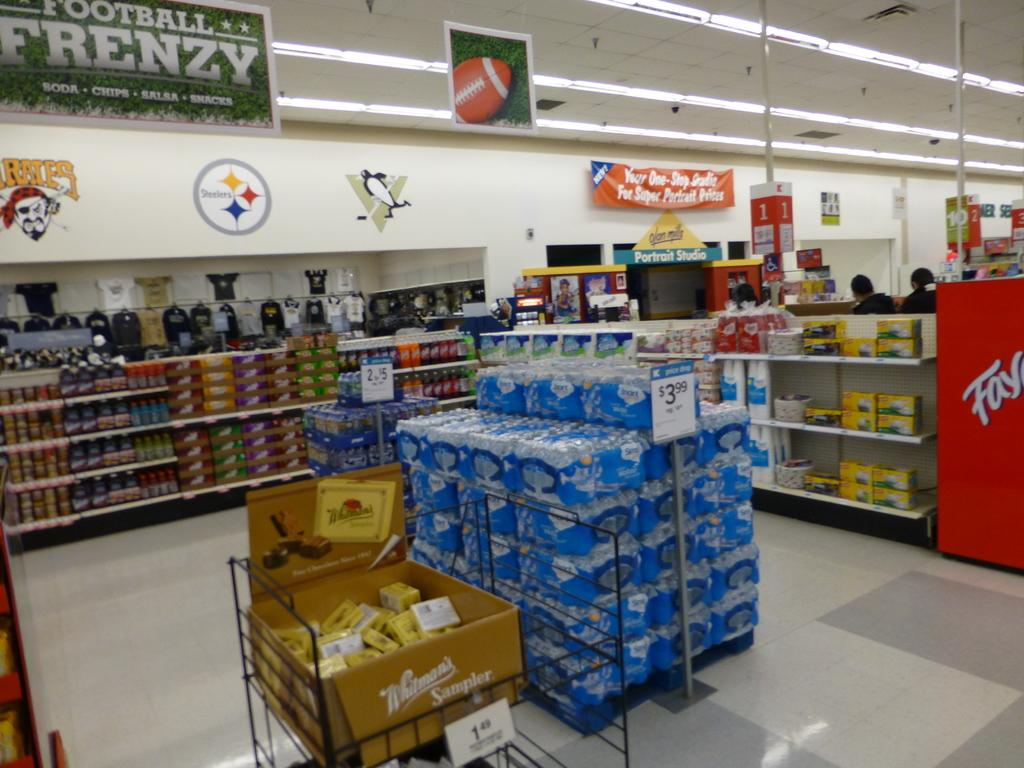What can be seen in the racks in the image? There are different types of items in the racks. Where might this image have been taken? The setting appears to be a shopping mall. What type of lighting is present in the image? There are lamps in the image. What type of advertisements or announcements can be seen in the image? There are posters in the image. What type of haircut is the spy getting in the image? There is no spy or haircut present in the image. What type of trade is being conducted in the image? There is no trade being conducted in the image; it is a shopping mall setting with racks of items. 